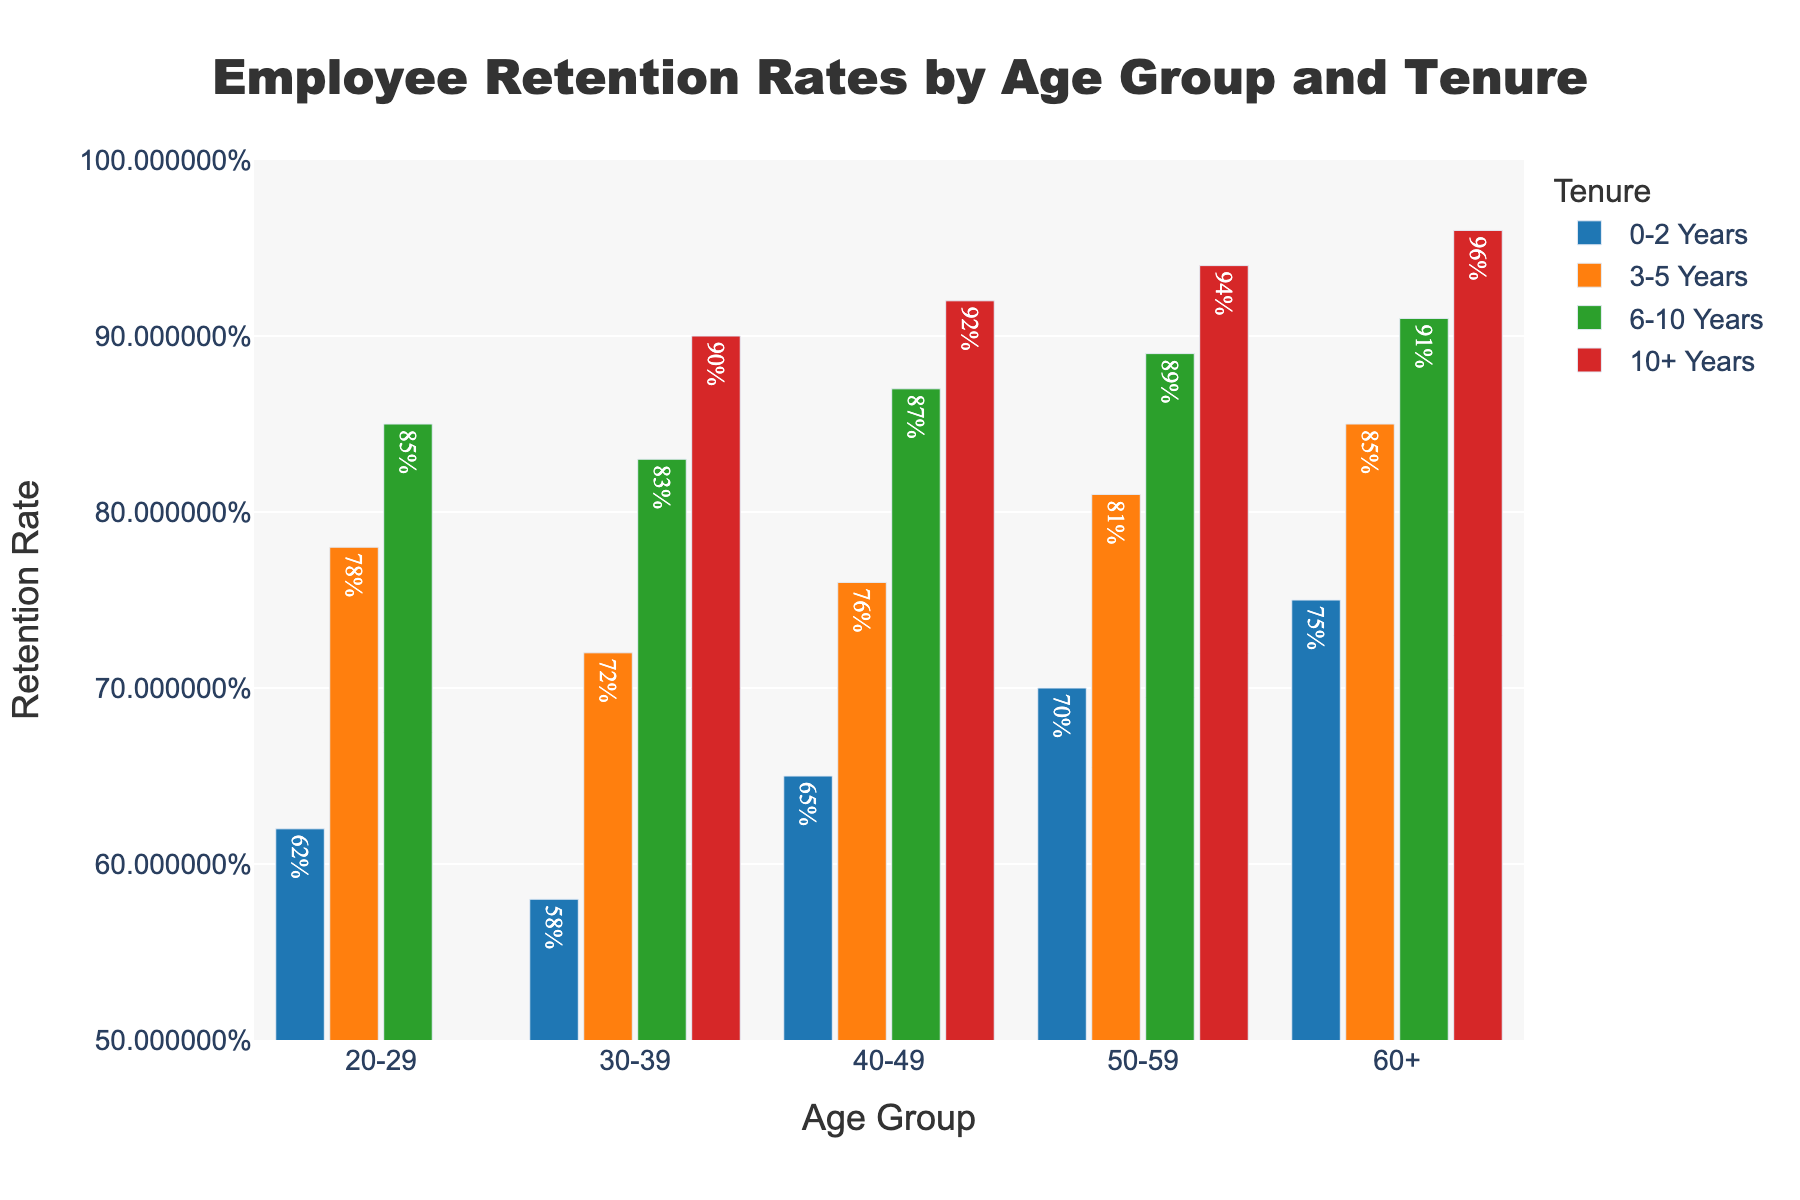What age group has the highest retention rate for employees with 10+ years of tenure? The 60+ age group shows the highest retention rate for employees with 10+ years of tenure. By looking at the height of the bars under the "10+ Years" category, the bar for the 60+ age group is the tallest and is labeled 96%.
Answer: 60+ How does the retention rate for employees aged 50-59 with 3-5 years of tenure compare to employees aged 30-39 with 3-5 years of tenure? The retention rate for employees aged 50-59 with 3-5 years of tenure is higher than that for employees aged 30-39. For the 50-59 age group, the rate is 81%, while for the 30-39 age group, it is 72%.
Answer: Higher What is the average retention rate for employees with 0-2 years of tenure across all age groups? First, extract the retention rates for each age group with 0-2 years of tenure: 62%, 58%, 65%, 70%, and 75%. Convert these percentages to decimal form (0.62, 0.58, 0.65, 0.70, 0.75), sum them (3.30), and divide by the number of groups (five).
Answer: 66% Which age group shows the most significant increase in retention rates from 0-2 years to 10+ years of tenure? Calculate the increase for each age group by subtracting the 0-2 years rate from the 10+ years rate and finding the maximum difference. Since "10+ Years" is N/A for 20-29, only consider other age groups: (30-39: 90%-58%=32%), (40-49: 92%-65%=27%), (50-59: 94%-70%=24%), (60+: 96%-75%=21%). The age group 30-39 had the most significant increase of 32%.
Answer: 30-39 What retention rate patterns are evident for employees with 3-5 years of tenure across different age groups? The pattern shows that the retention rate generally increases with the age group. Specifically, the rates are 78% (20-29), 72% (30-39), 76% (40-49), 81% (50-59), and 85% (60+). Except for a dip in the 30-39 group, the rates rise.
Answer: Increases with age For the age group 40-49, how does the retention rate difference between 3-5 years and 6-10 years of tenure compare to the same difference for the 50-59 age group? For the 40-49 age group: 87% (6-10 years) - 76% (3-5 years) = 11%. For the 50-59 age group: 89% (6-10 years) - 81% (3-5 years) = 8%. The difference is larger for the 40-49 age group.
Answer: Larger for 40-49 What is the retention rate for employees aged 20-29 with 6-10 years of tenure? Look at the chart for the 20-29 age group and observe the bar corresponding to the 6-10 years of tenure, where the height and the label both indicate the retention rate. It shows 85%.
Answer: 85% How does the retention rate for employees aged 60+ with 0-2 years of tenure compare to those aged 30-39 with 6-10 years of tenure? The retention rate for employees aged 60+ with 0-2 years of tenure is 75%, while for those aged 30-39 with 6-10 years of tenure, it is 83%. By direct comparison, 75% is less than 83%.
Answer: Lower 